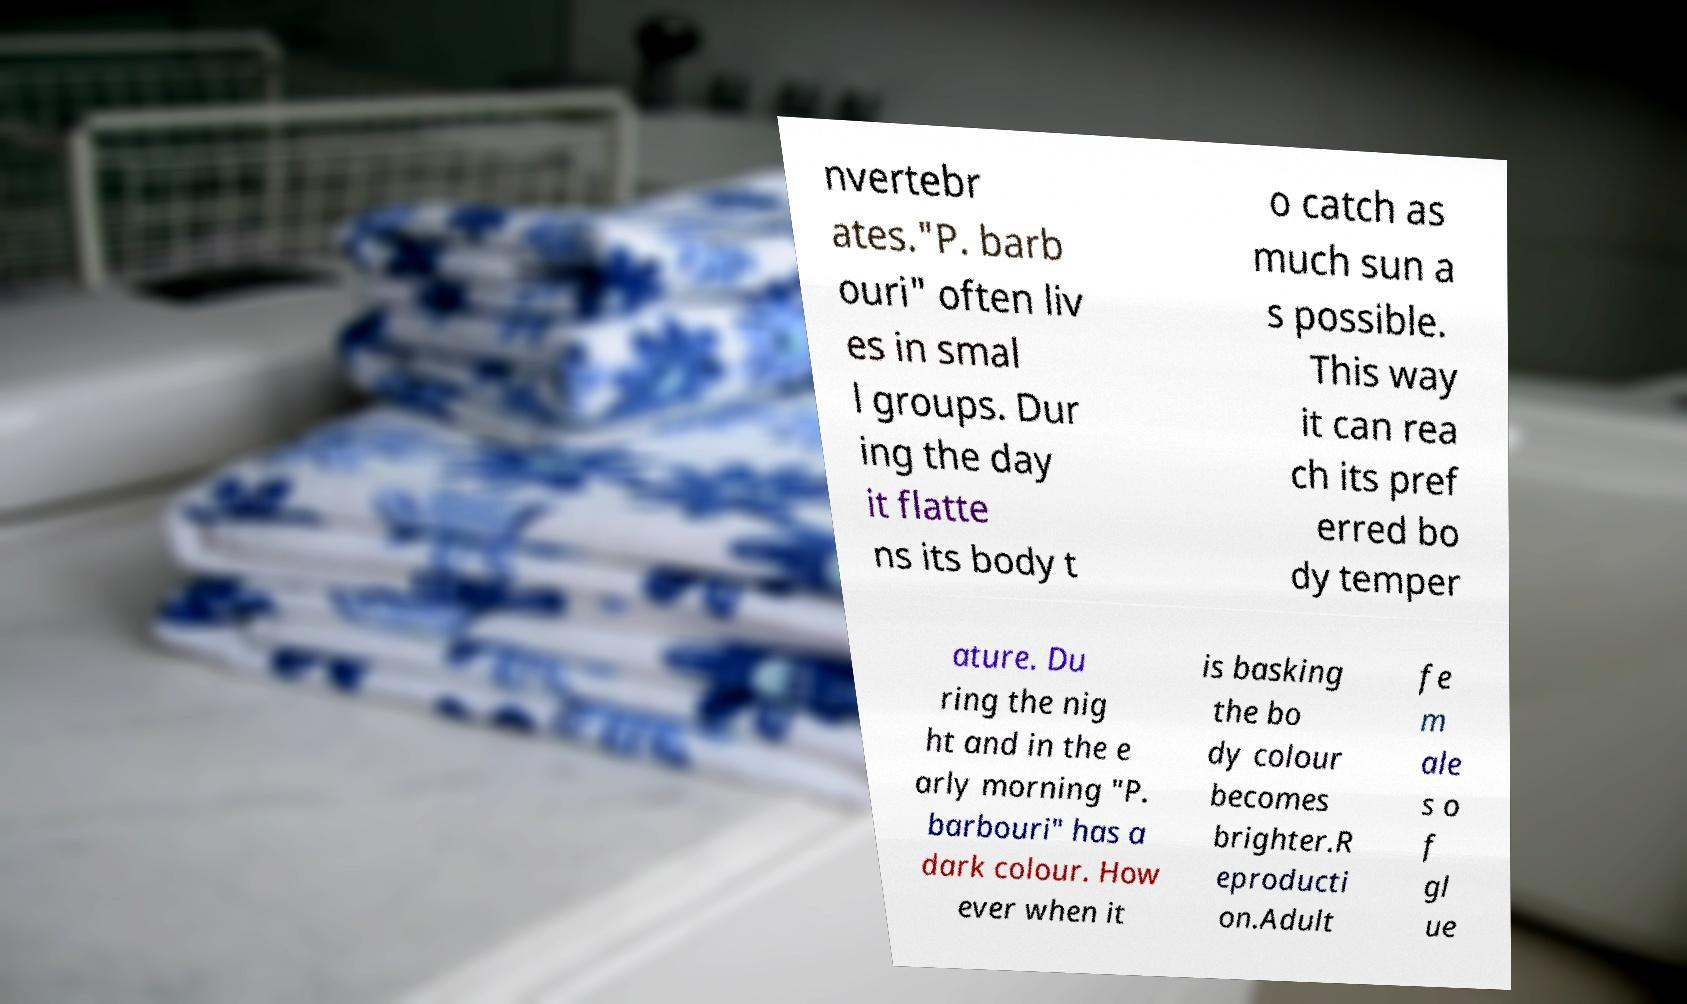Can you accurately transcribe the text from the provided image for me? nvertebr ates."P. barb ouri" often liv es in smal l groups. Dur ing the day it flatte ns its body t o catch as much sun a s possible. This way it can rea ch its pref erred bo dy temper ature. Du ring the nig ht and in the e arly morning "P. barbouri" has a dark colour. How ever when it is basking the bo dy colour becomes brighter.R eproducti on.Adult fe m ale s o f gl ue 